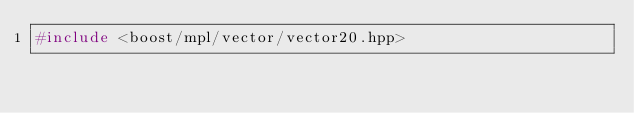Convert code to text. <code><loc_0><loc_0><loc_500><loc_500><_C++_>#include <boost/mpl/vector/vector20.hpp>
</code> 